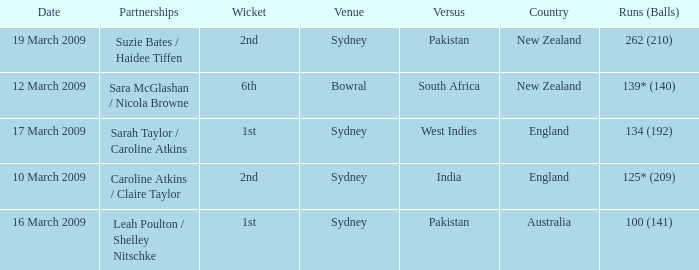How many times was the opponent country India?  1.0. 